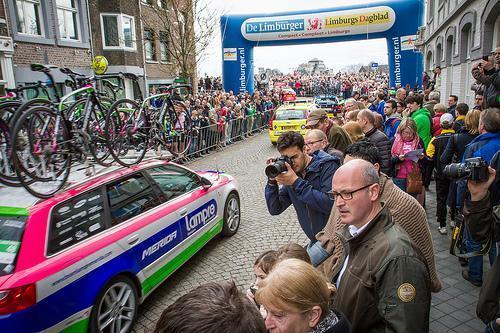How many cars are visible?
Give a very brief answer. 3. 